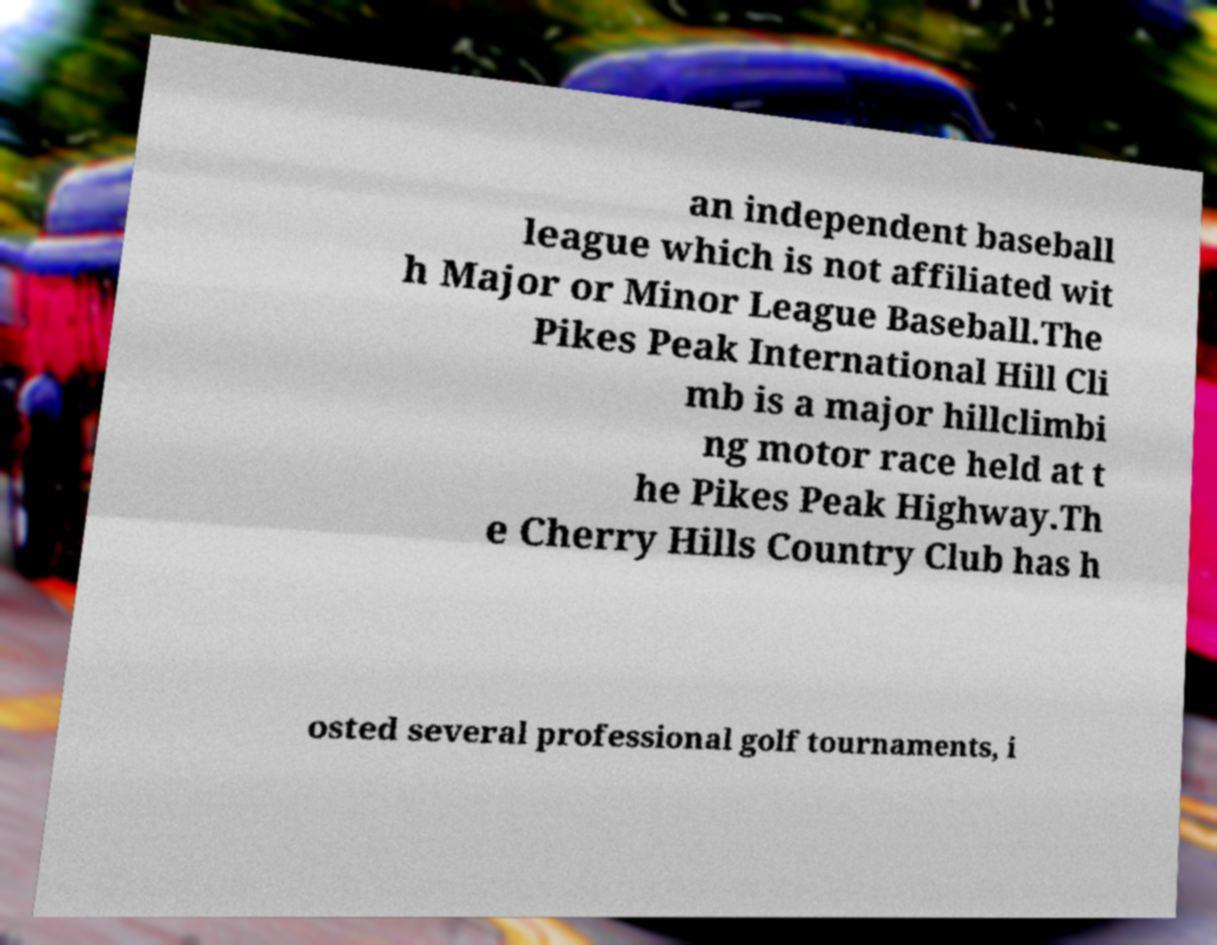Could you extract and type out the text from this image? an independent baseball league which is not affiliated wit h Major or Minor League Baseball.The Pikes Peak International Hill Cli mb is a major hillclimbi ng motor race held at t he Pikes Peak Highway.Th e Cherry Hills Country Club has h osted several professional golf tournaments, i 